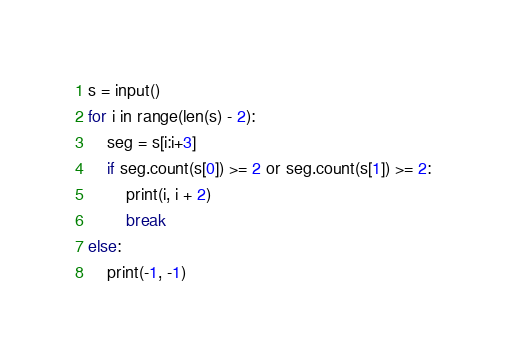<code> <loc_0><loc_0><loc_500><loc_500><_Python_>s = input()
for i in range(len(s) - 2):
    seg = s[i:i+3]
    if seg.count(s[0]) >= 2 or seg.count(s[1]) >= 2:
        print(i, i + 2)
        break
else:
    print(-1, -1)
</code> 